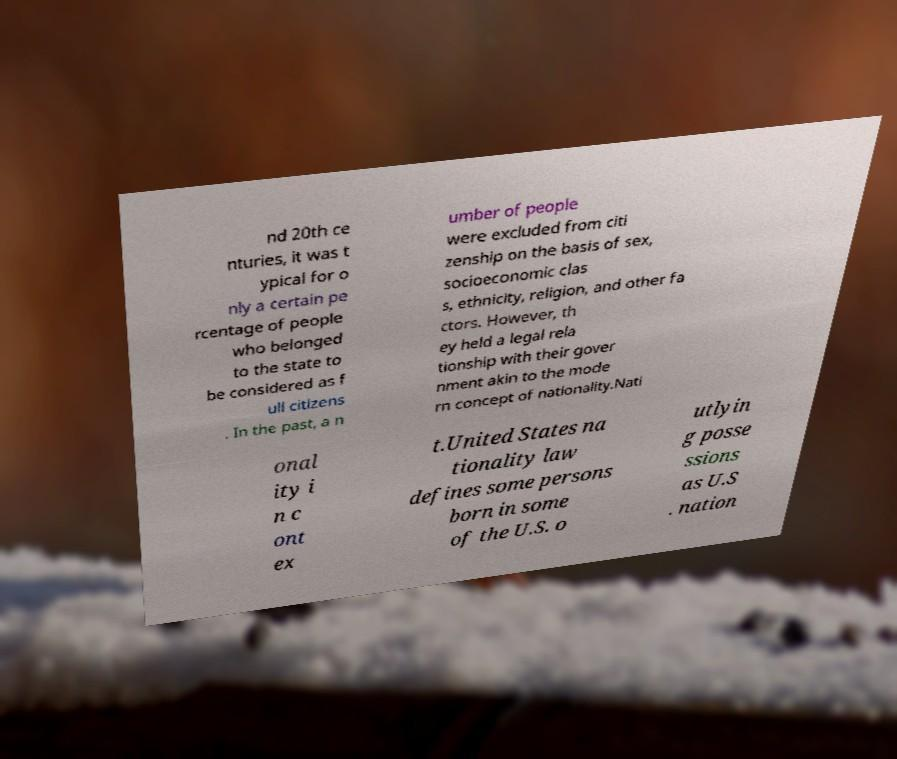Please read and relay the text visible in this image. What does it say? nd 20th ce nturies, it was t ypical for o nly a certain pe rcentage of people who belonged to the state to be considered as f ull citizens . In the past, a n umber of people were excluded from citi zenship on the basis of sex, socioeconomic clas s, ethnicity, religion, and other fa ctors. However, th ey held a legal rela tionship with their gover nment akin to the mode rn concept of nationality.Nati onal ity i n c ont ex t.United States na tionality law defines some persons born in some of the U.S. o utlyin g posse ssions as U.S . nation 